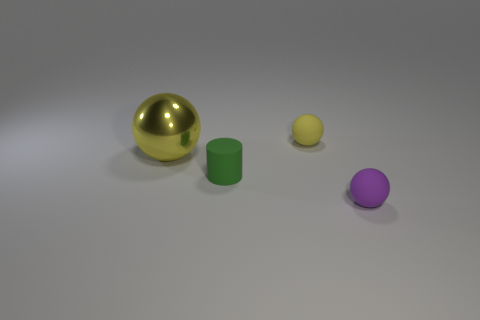Is there anything else that is the same size as the metallic thing?
Your answer should be very brief. No. What is the small sphere on the left side of the purple thing made of?
Provide a short and direct response. Rubber. Are there any other things that have the same material as the large thing?
Provide a short and direct response. No. What is the material of the other tiny thing that is the same shape as the small purple matte thing?
Offer a very short reply. Rubber. Are there an equal number of balls that are to the right of the small green rubber cylinder and metallic balls?
Your answer should be very brief. No. There is a ball that is both behind the green object and to the right of the metallic object; what size is it?
Make the answer very short. Small. Are there any other things that are the same color as the shiny object?
Make the answer very short. Yes. What size is the matte ball that is to the right of the tiny sphere on the left side of the tiny purple object?
Offer a very short reply. Small. What color is the object that is right of the tiny cylinder and behind the purple ball?
Provide a succinct answer. Yellow. What number of other objects are there of the same size as the yellow metallic thing?
Keep it short and to the point. 0. 